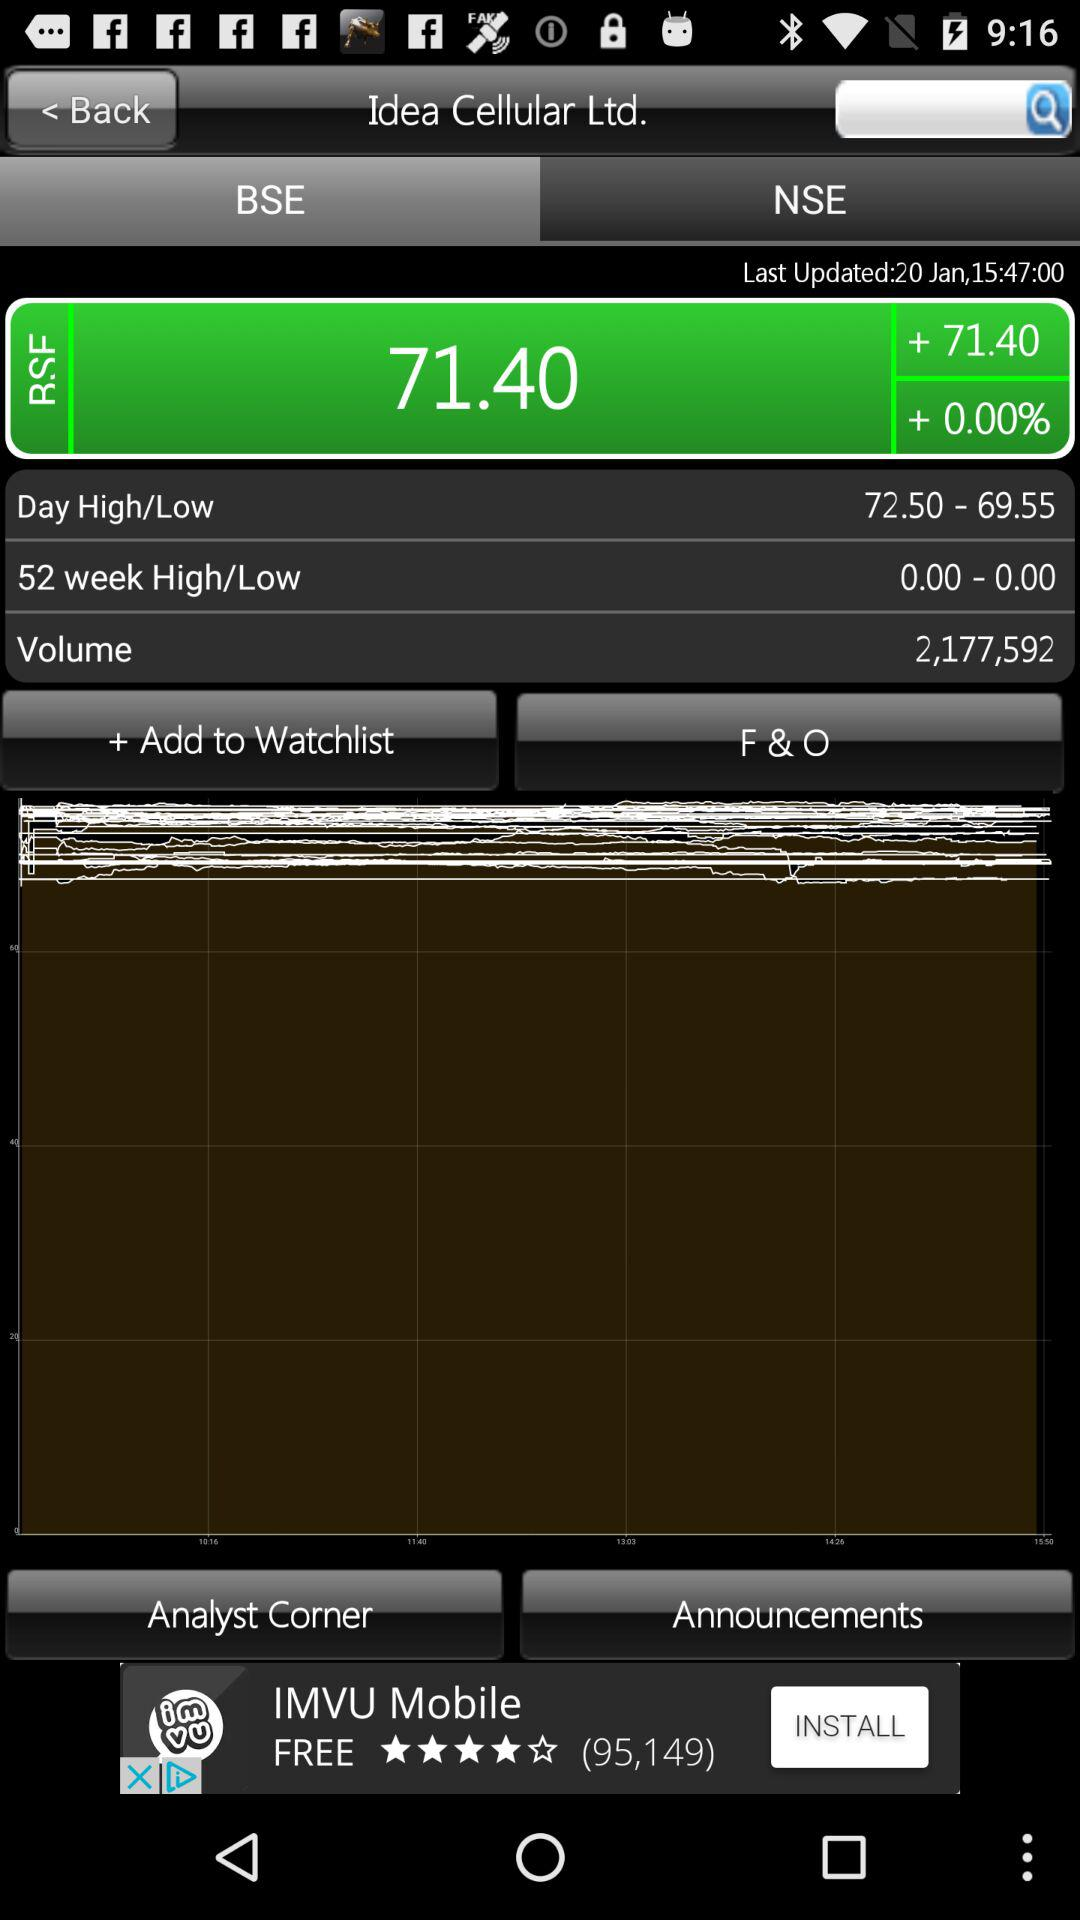How much value is there in the 52-week high and low for BSE? BSE's 52-week high and low values are 0.00 and 0.00, respectively. 